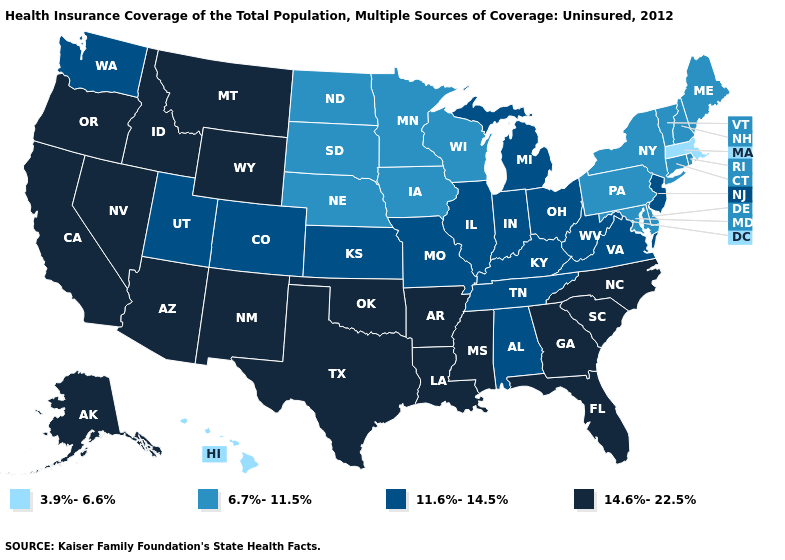Among the states that border Oklahoma , does Colorado have the lowest value?
Quick response, please. Yes. Name the states that have a value in the range 6.7%-11.5%?
Give a very brief answer. Connecticut, Delaware, Iowa, Maine, Maryland, Minnesota, Nebraska, New Hampshire, New York, North Dakota, Pennsylvania, Rhode Island, South Dakota, Vermont, Wisconsin. Name the states that have a value in the range 14.6%-22.5%?
Short answer required. Alaska, Arizona, Arkansas, California, Florida, Georgia, Idaho, Louisiana, Mississippi, Montana, Nevada, New Mexico, North Carolina, Oklahoma, Oregon, South Carolina, Texas, Wyoming. Does Hawaii have the lowest value in the USA?
Keep it brief. Yes. Name the states that have a value in the range 6.7%-11.5%?
Keep it brief. Connecticut, Delaware, Iowa, Maine, Maryland, Minnesota, Nebraska, New Hampshire, New York, North Dakota, Pennsylvania, Rhode Island, South Dakota, Vermont, Wisconsin. Is the legend a continuous bar?
Quick response, please. No. Name the states that have a value in the range 6.7%-11.5%?
Answer briefly. Connecticut, Delaware, Iowa, Maine, Maryland, Minnesota, Nebraska, New Hampshire, New York, North Dakota, Pennsylvania, Rhode Island, South Dakota, Vermont, Wisconsin. What is the value of Montana?
Write a very short answer. 14.6%-22.5%. What is the highest value in the West ?
Answer briefly. 14.6%-22.5%. What is the value of West Virginia?
Answer briefly. 11.6%-14.5%. Among the states that border Georgia , does Florida have the highest value?
Be succinct. Yes. What is the lowest value in the South?
Keep it brief. 6.7%-11.5%. Name the states that have a value in the range 14.6%-22.5%?
Quick response, please. Alaska, Arizona, Arkansas, California, Florida, Georgia, Idaho, Louisiana, Mississippi, Montana, Nevada, New Mexico, North Carolina, Oklahoma, Oregon, South Carolina, Texas, Wyoming. 